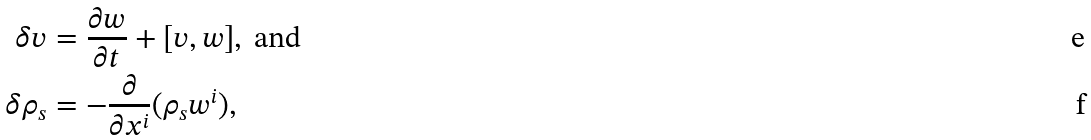<formula> <loc_0><loc_0><loc_500><loc_500>\delta v & = \frac { \partial w } { \partial t } + [ v , w ] , \ \text {and} \\ \delta \rho _ { s } & = - \frac { \partial } { \partial x ^ { i } } ( \rho _ { s } w ^ { i } ) ,</formula> 